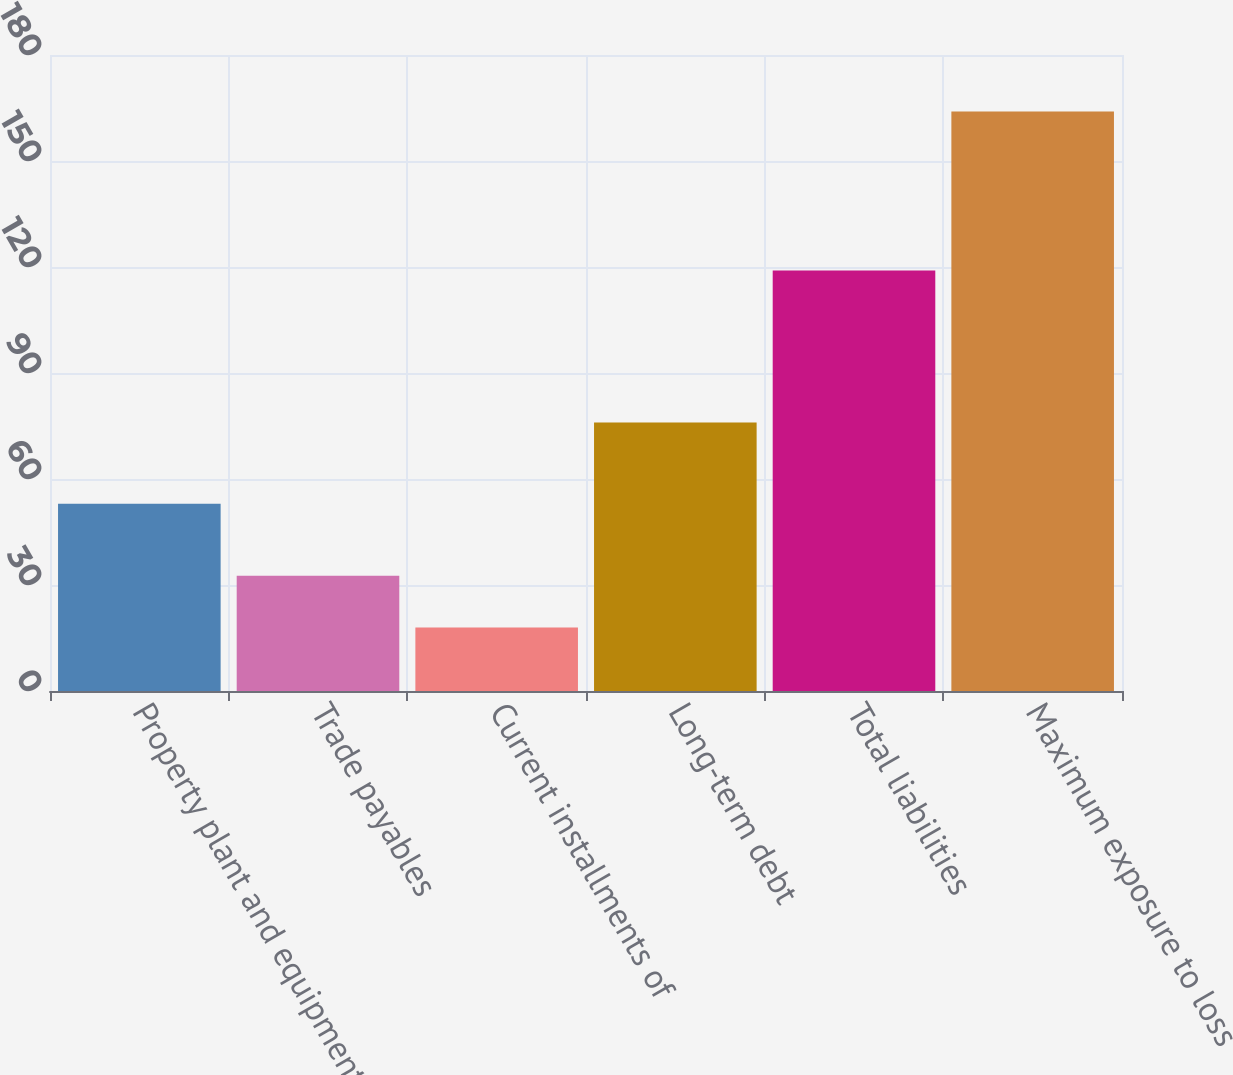Convert chart. <chart><loc_0><loc_0><loc_500><loc_500><bar_chart><fcel>Property plant and equipment<fcel>Trade payables<fcel>Current installments of<fcel>Long-term debt<fcel>Total liabilities<fcel>Maximum exposure to loss<nl><fcel>53<fcel>32.6<fcel>18<fcel>76<fcel>119<fcel>164<nl></chart> 